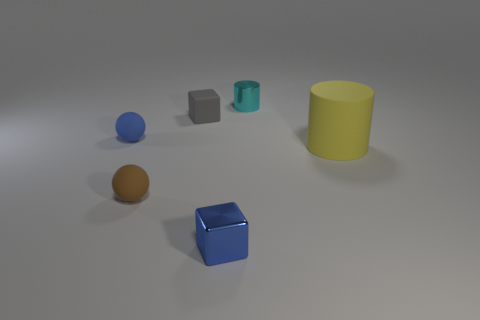Are there any other things that are the same size as the rubber cylinder?
Offer a very short reply. No. There is a sphere to the right of the blue matte ball; is its size the same as the blue cube?
Ensure brevity in your answer.  Yes. How many matte things are either brown balls or yellow cylinders?
Provide a succinct answer. 2. What is the size of the blue thing on the left side of the gray rubber object?
Offer a very short reply. Small. Does the small brown thing have the same shape as the small cyan metal object?
Keep it short and to the point. No. How many small objects are brown spheres or blue rubber cylinders?
Your answer should be very brief. 1. Are there any blue spheres on the left side of the small brown rubber ball?
Provide a short and direct response. Yes. Are there an equal number of big yellow rubber cylinders that are to the right of the blue block and big blue metallic cylinders?
Make the answer very short. No. There is a metal object that is the same shape as the yellow rubber thing; what is its size?
Give a very brief answer. Small. Do the brown rubber thing and the shiny thing in front of the matte cylinder have the same shape?
Your answer should be compact. No. 